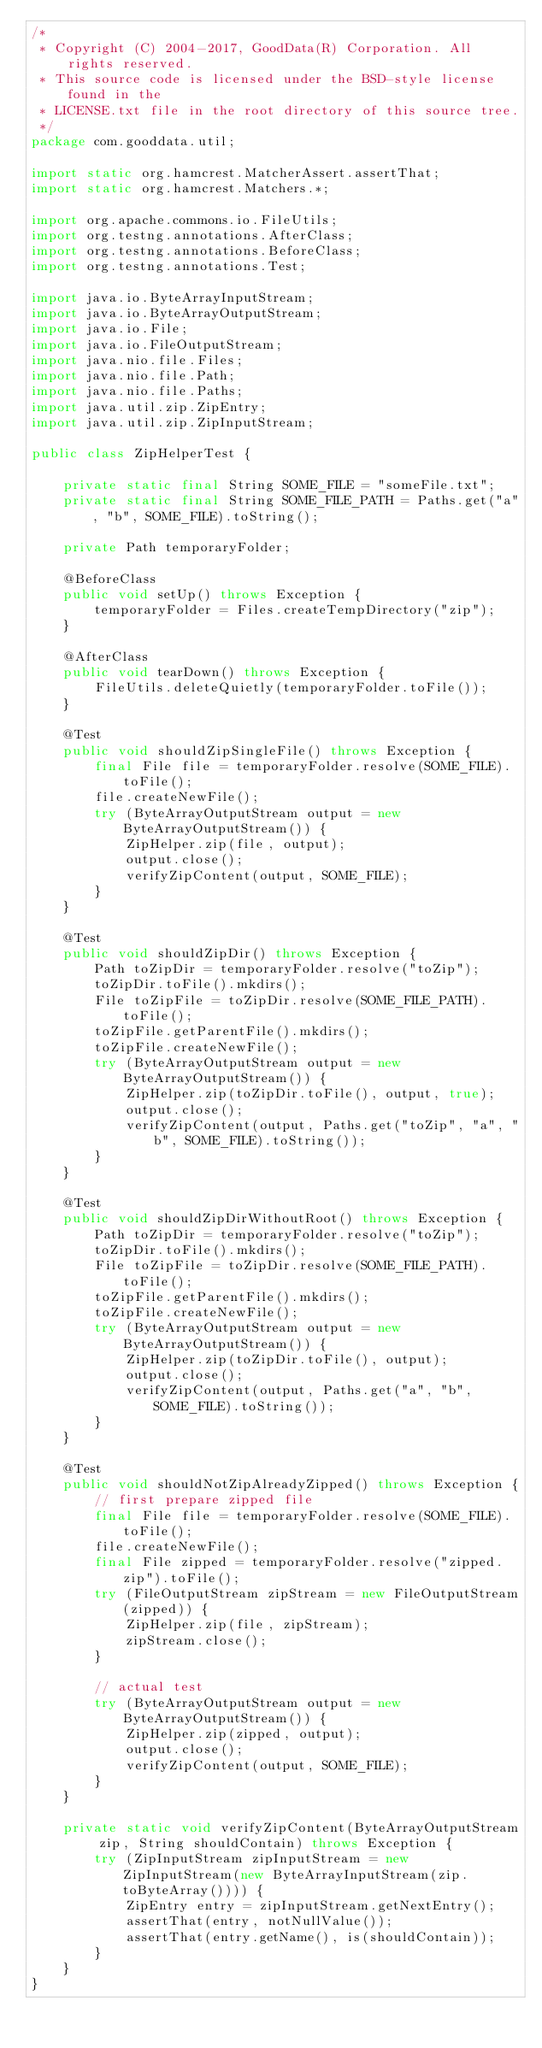Convert code to text. <code><loc_0><loc_0><loc_500><loc_500><_Java_>/*
 * Copyright (C) 2004-2017, GoodData(R) Corporation. All rights reserved.
 * This source code is licensed under the BSD-style license found in the
 * LICENSE.txt file in the root directory of this source tree.
 */
package com.gooddata.util;

import static org.hamcrest.MatcherAssert.assertThat;
import static org.hamcrest.Matchers.*;

import org.apache.commons.io.FileUtils;
import org.testng.annotations.AfterClass;
import org.testng.annotations.BeforeClass;
import org.testng.annotations.Test;

import java.io.ByteArrayInputStream;
import java.io.ByteArrayOutputStream;
import java.io.File;
import java.io.FileOutputStream;
import java.nio.file.Files;
import java.nio.file.Path;
import java.nio.file.Paths;
import java.util.zip.ZipEntry;
import java.util.zip.ZipInputStream;

public class ZipHelperTest {

    private static final String SOME_FILE = "someFile.txt";
    private static final String SOME_FILE_PATH = Paths.get("a", "b", SOME_FILE).toString();

    private Path temporaryFolder;

    @BeforeClass
    public void setUp() throws Exception {
        temporaryFolder = Files.createTempDirectory("zip");
    }

    @AfterClass
    public void tearDown() throws Exception {
        FileUtils.deleteQuietly(temporaryFolder.toFile());
    }

    @Test
    public void shouldZipSingleFile() throws Exception {
        final File file = temporaryFolder.resolve(SOME_FILE).toFile();
        file.createNewFile();
        try (ByteArrayOutputStream output = new ByteArrayOutputStream()) {
            ZipHelper.zip(file, output);
            output.close();
            verifyZipContent(output, SOME_FILE);
        }
    }

    @Test
    public void shouldZipDir() throws Exception {
        Path toZipDir = temporaryFolder.resolve("toZip");
        toZipDir.toFile().mkdirs();
        File toZipFile = toZipDir.resolve(SOME_FILE_PATH).toFile();
        toZipFile.getParentFile().mkdirs();
        toZipFile.createNewFile();
        try (ByteArrayOutputStream output = new ByteArrayOutputStream()) {
            ZipHelper.zip(toZipDir.toFile(), output, true);
            output.close();
            verifyZipContent(output, Paths.get("toZip", "a", "b", SOME_FILE).toString());
        }
    }

    @Test
    public void shouldZipDirWithoutRoot() throws Exception {
        Path toZipDir = temporaryFolder.resolve("toZip");
        toZipDir.toFile().mkdirs();
        File toZipFile = toZipDir.resolve(SOME_FILE_PATH).toFile();
        toZipFile.getParentFile().mkdirs();
        toZipFile.createNewFile();
        try (ByteArrayOutputStream output = new ByteArrayOutputStream()) {
            ZipHelper.zip(toZipDir.toFile(), output);
            output.close();
            verifyZipContent(output, Paths.get("a", "b", SOME_FILE).toString());
        }
    }

    @Test
    public void shouldNotZipAlreadyZipped() throws Exception {
        // first prepare zipped file
        final File file = temporaryFolder.resolve(SOME_FILE).toFile();
        file.createNewFile();
        final File zipped = temporaryFolder.resolve("zipped.zip").toFile();
        try (FileOutputStream zipStream = new FileOutputStream(zipped)) {
            ZipHelper.zip(file, zipStream);
            zipStream.close();
        }

        // actual test
        try (ByteArrayOutputStream output = new ByteArrayOutputStream()) {
            ZipHelper.zip(zipped, output);
            output.close();
            verifyZipContent(output, SOME_FILE);
        }
    }

    private static void verifyZipContent(ByteArrayOutputStream zip, String shouldContain) throws Exception {
        try (ZipInputStream zipInputStream = new ZipInputStream(new ByteArrayInputStream(zip.toByteArray()))) {
            ZipEntry entry = zipInputStream.getNextEntry();
            assertThat(entry, notNullValue());
            assertThat(entry.getName(), is(shouldContain));
        }
    }
}</code> 